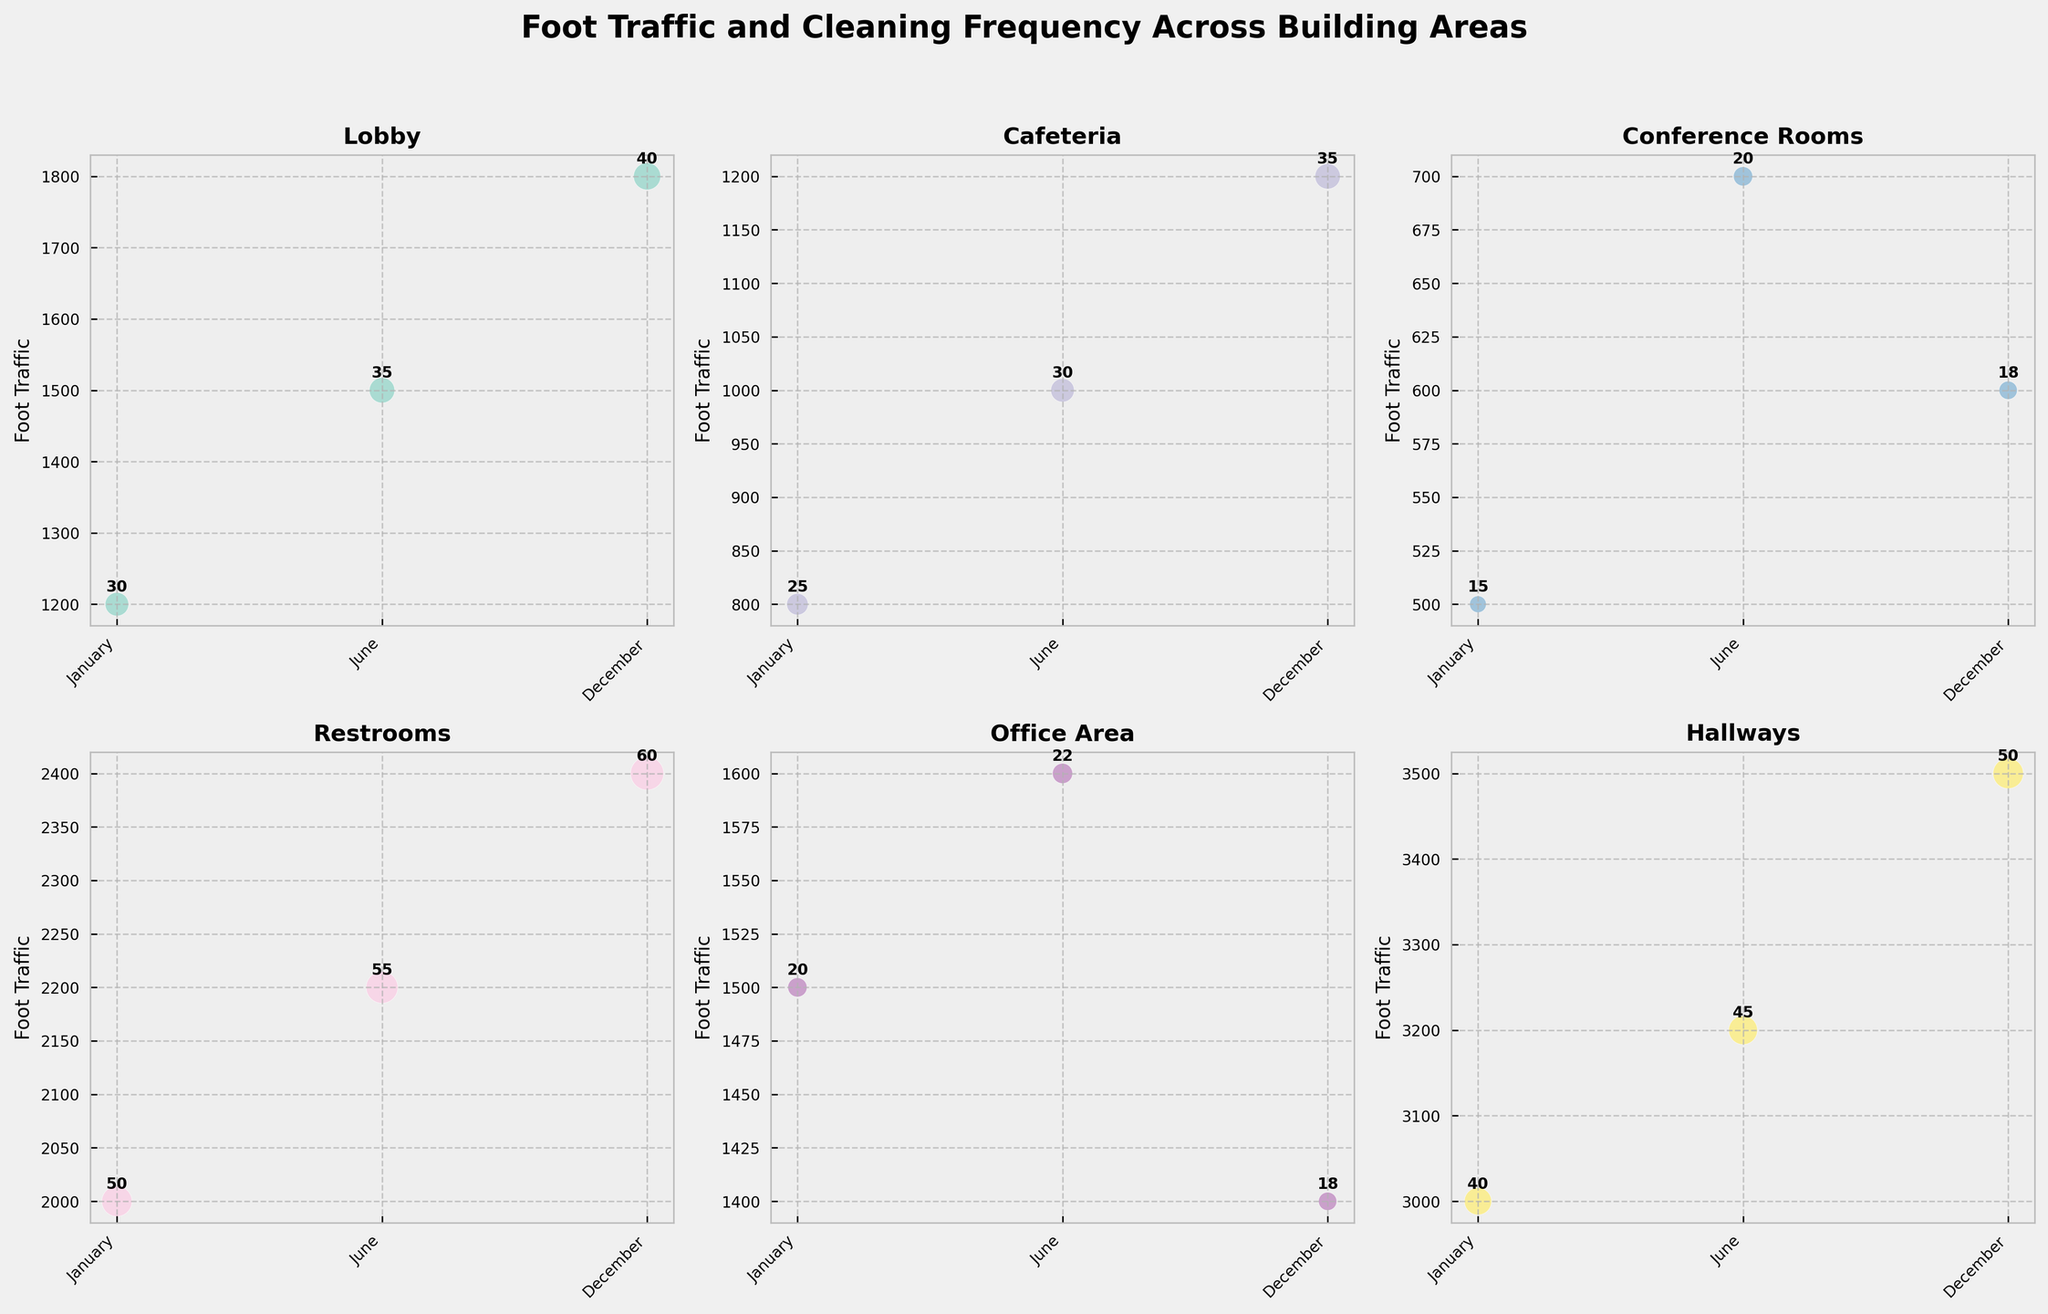How many building areas are represented in the figure? The figure's subplot consists of scatter bubbles for each unique building area. By counting the titles of each subplot, we determine there are six building areas.
Answer: 6 Which building area has the highest foot traffic in December? To find the highest foot traffic in December, look at the December data points across all subplots. The Hallways area has the largest bubble and highest y-axis value for December.
Answer: Hallways Which month sees the highest cleaning frequency in the Restrooms area? In the Restrooms subplot, compare the bubble sizes for all months. December has the largest bubble, indicating the highest cleaning frequency.
Answer: December Compare the foot traffic of the Lobby area between January and December. In the Lobby subplot, check the y-values for January and December. Foot traffic in January is 1200, while December is 1800. December has higher foot traffic.
Answer: December What is the trend in foot traffic for the Cafeteria area? In the Cafeteria subplot, compare the foot traffic values across January (800), June (1000), and December (1200). The trend shows an increasing pattern over the months.
Answer: Increasing Which building area requires the least cleaning frequency in June? Compare bubble sizes across all subplots for June. Conference Rooms have the smallest bubble with a cleaning frequency of 20.
Answer: Conference Rooms What is the average foot traffic in the Office Area across the year? Foot traffic in the Office Area for January is 1500, June is 1600, and December is 1400. Sum these values to get 4500, then divide by 3 months: 4500/3 = 1500.
Answer: 1500 Which area has the most volatile (largest range) foot traffic throughout the year? Calculate the range for each area by subtracting the lowest foot traffic value from the highest. Hallways have the highest range (3500 - 3000 = 500).
Answer: Hallways Is there a correlation between foot traffic and cleaning frequency? By observing the bubble sizes and y-values in each subplot, we note that areas with higher foot traffic have larger bubbles, indicating a positive correlation between foot traffic and cleaning frequency.
Answer: Yes In which month does the Hallway area experience its peak foot traffic, and what is the value? In the Hallways subplot, look at the y-values for January, June, and December. December has the highest value at 3500.
Answer: December, 3500 